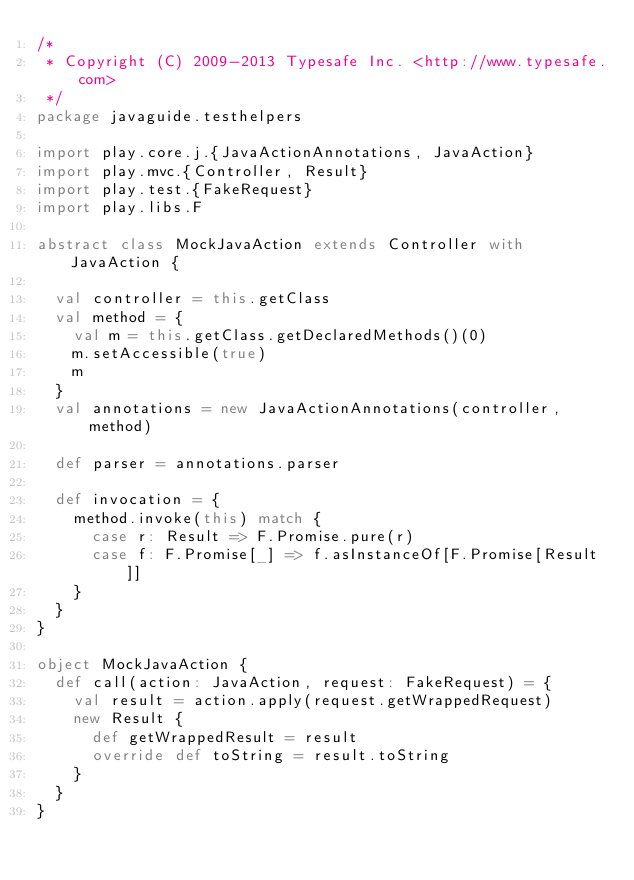<code> <loc_0><loc_0><loc_500><loc_500><_Scala_>/*
 * Copyright (C) 2009-2013 Typesafe Inc. <http://www.typesafe.com>
 */
package javaguide.testhelpers

import play.core.j.{JavaActionAnnotations, JavaAction}
import play.mvc.{Controller, Result}
import play.test.{FakeRequest}
import play.libs.F

abstract class MockJavaAction extends Controller with JavaAction {

  val controller = this.getClass
  val method = {
    val m = this.getClass.getDeclaredMethods()(0)
    m.setAccessible(true)
    m
  }
  val annotations = new JavaActionAnnotations(controller, method)

  def parser = annotations.parser

  def invocation = {
    method.invoke(this) match {
      case r: Result => F.Promise.pure(r)
      case f: F.Promise[_] => f.asInstanceOf[F.Promise[Result]]
    }
  }
}

object MockJavaAction {
  def call(action: JavaAction, request: FakeRequest) = {
    val result = action.apply(request.getWrappedRequest)
    new Result {
      def getWrappedResult = result
      override def toString = result.toString
    }
  }
}
</code> 